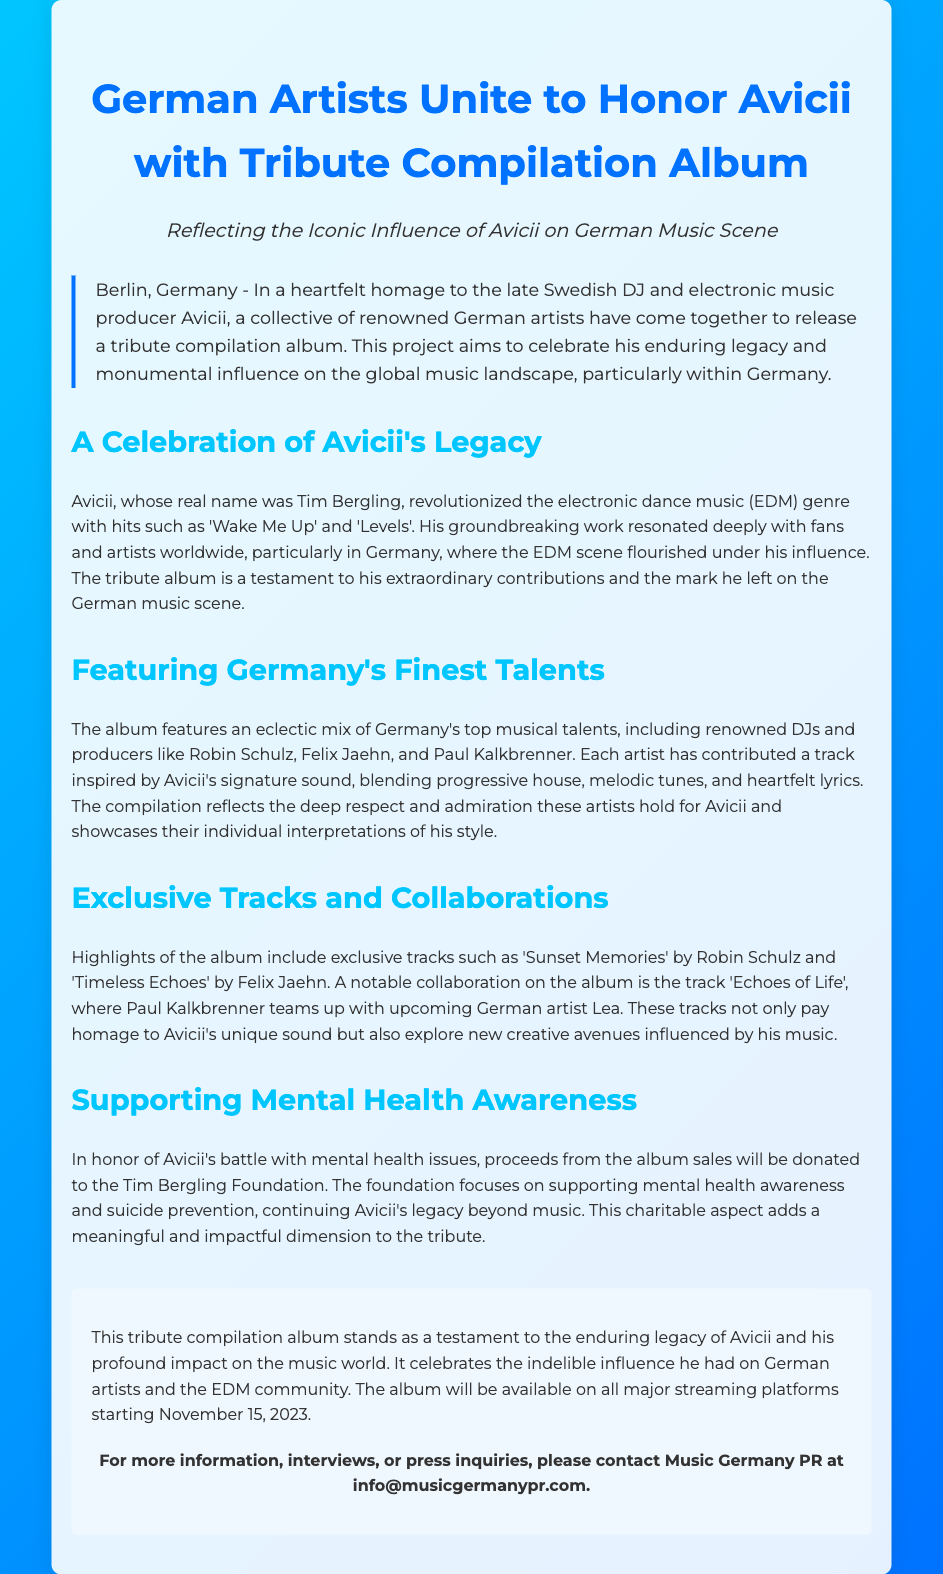What is the title of the album? The title of the album is provided in the header of the press release.
Answer: Tribute Compilation Album Who are two artists featured on the album? The press release mentions specific artists featured on the album.
Answer: Robin Schulz and Felix Jaehn When will the album be available on streaming platforms? The release date for the album is specified in the closing section of the document.
Answer: November 15, 2023 What foundation will benefit from the album proceeds? The document outlines the charitable aspect related to Avicii's legacy.
Answer: Tim Bergling Foundation What genre of music did Avicii primarily influence? The press release describes Avicii's impact on a specific genre of music.
Answer: Electronic dance music (EDM) How many exclusive tracks are highlighted in the album? The press release mentions specific tracks as highlights, specifically naming those mentioned.
Answer: Two exclusive tracks What is the purpose of the tribute compilation album? The document states the motivation behind creating the tribute album.
Answer: To honor Avicii's legacy Which artist collaborated with Paul Kalkbrenner on a track? The press release identifies a specific collaboration featured in the album.
Answer: Lea What is the main focus of the Tim Bergling Foundation? The press release describes the charitable focus of the foundation supported by the album.
Answer: Mental health awareness 